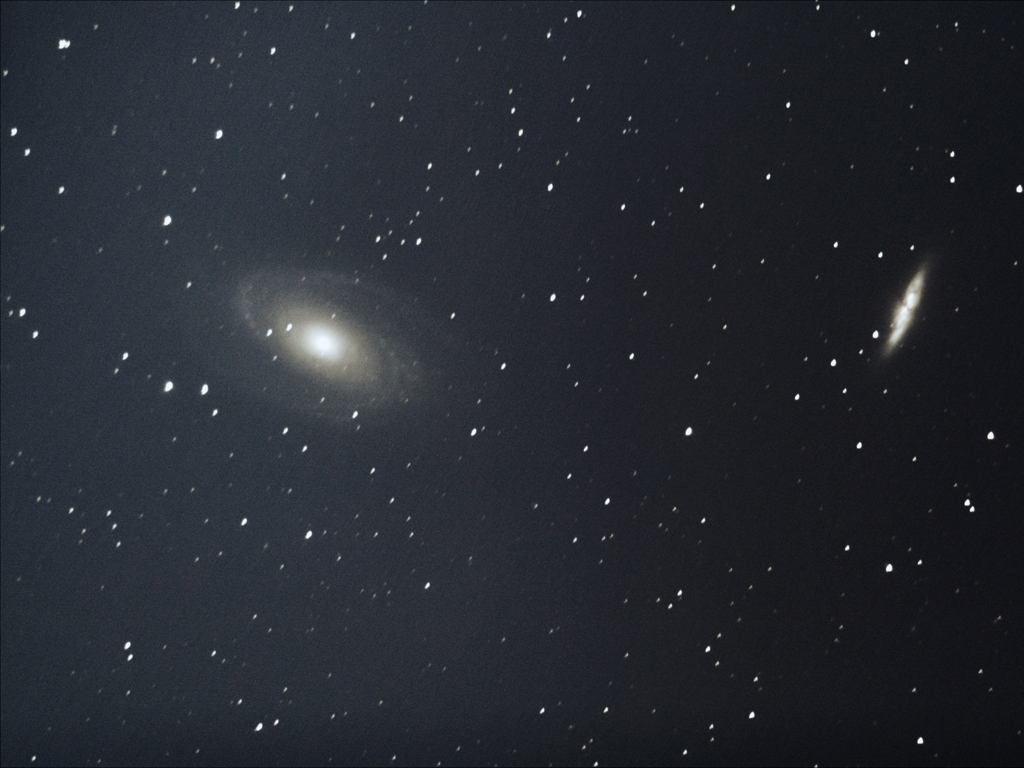What does the presence of multiple galaxies in this image suggest about the larger structure of the universe? The presence of multiple galaxies indicates that galaxies are not isolated but often part of larger structures such as galaxy clusters or superclusters. This hints at the large-scale web-like structure of the universe, where galaxies are interconnected by gravity. Can the distances to these galaxies be determined from this image alone? Determining precise distances requires more information than what a single image can provide, such as redshift data or standard candles like Cepheid variables in the galaxies. However, relative brightness and size can offer rough comparative estimates. 